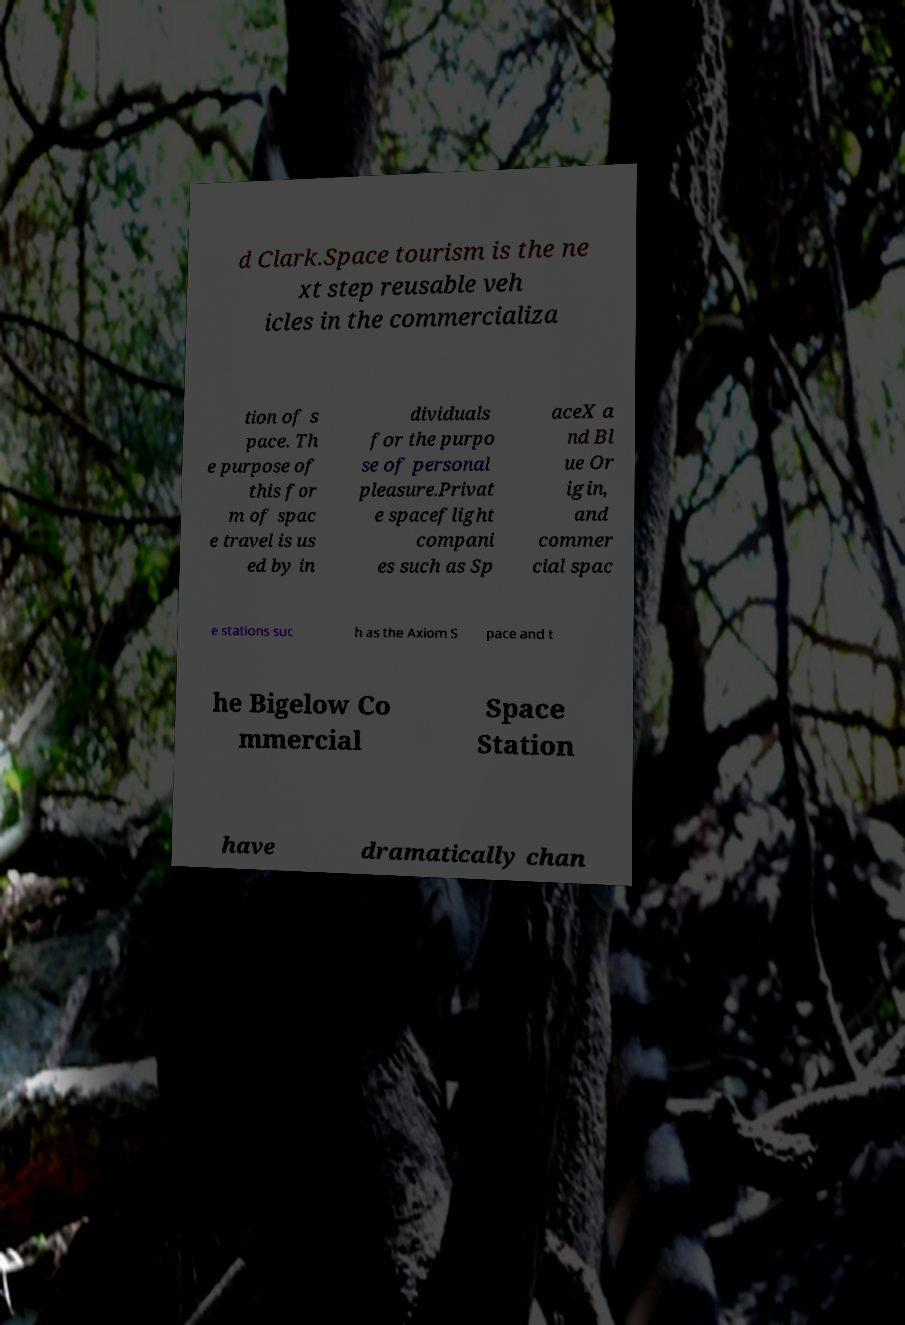Can you read and provide the text displayed in the image?This photo seems to have some interesting text. Can you extract and type it out for me? d Clark.Space tourism is the ne xt step reusable veh icles in the commercializa tion of s pace. Th e purpose of this for m of spac e travel is us ed by in dividuals for the purpo se of personal pleasure.Privat e spaceflight compani es such as Sp aceX a nd Bl ue Or igin, and commer cial spac e stations suc h as the Axiom S pace and t he Bigelow Co mmercial Space Station have dramatically chan 